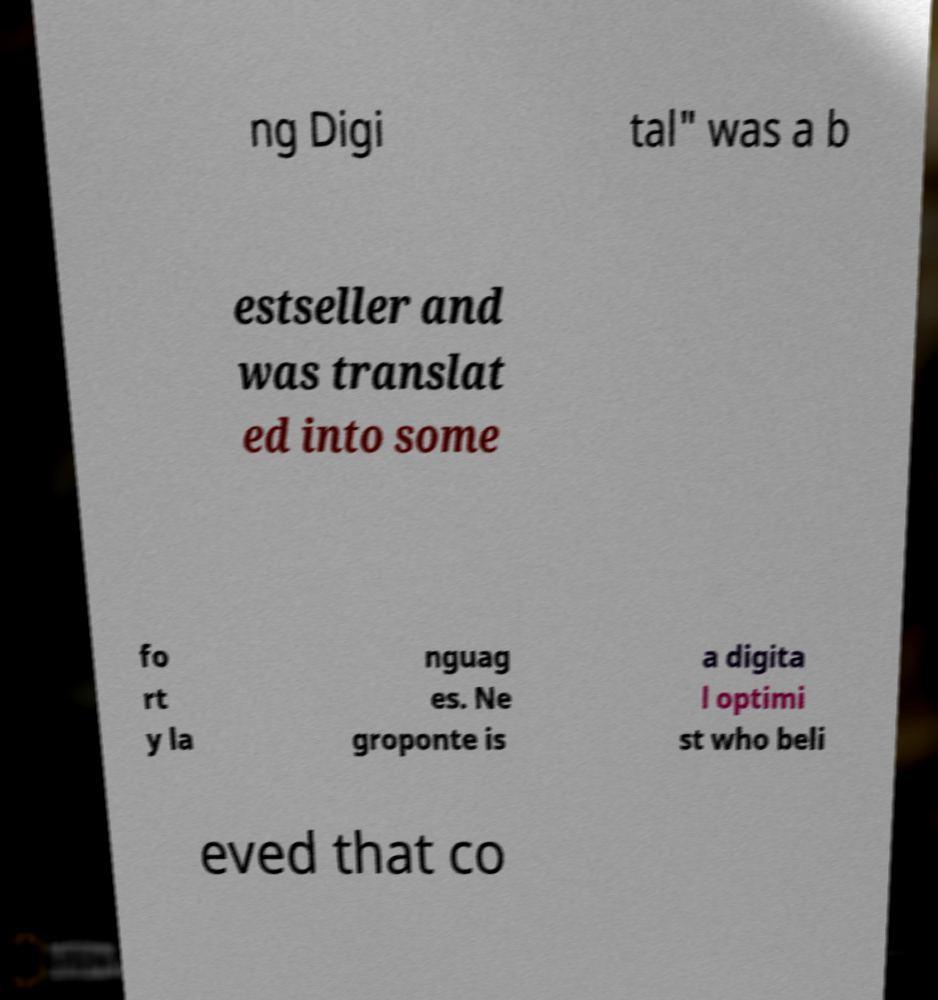There's text embedded in this image that I need extracted. Can you transcribe it verbatim? ng Digi tal" was a b estseller and was translat ed into some fo rt y la nguag es. Ne groponte is a digita l optimi st who beli eved that co 